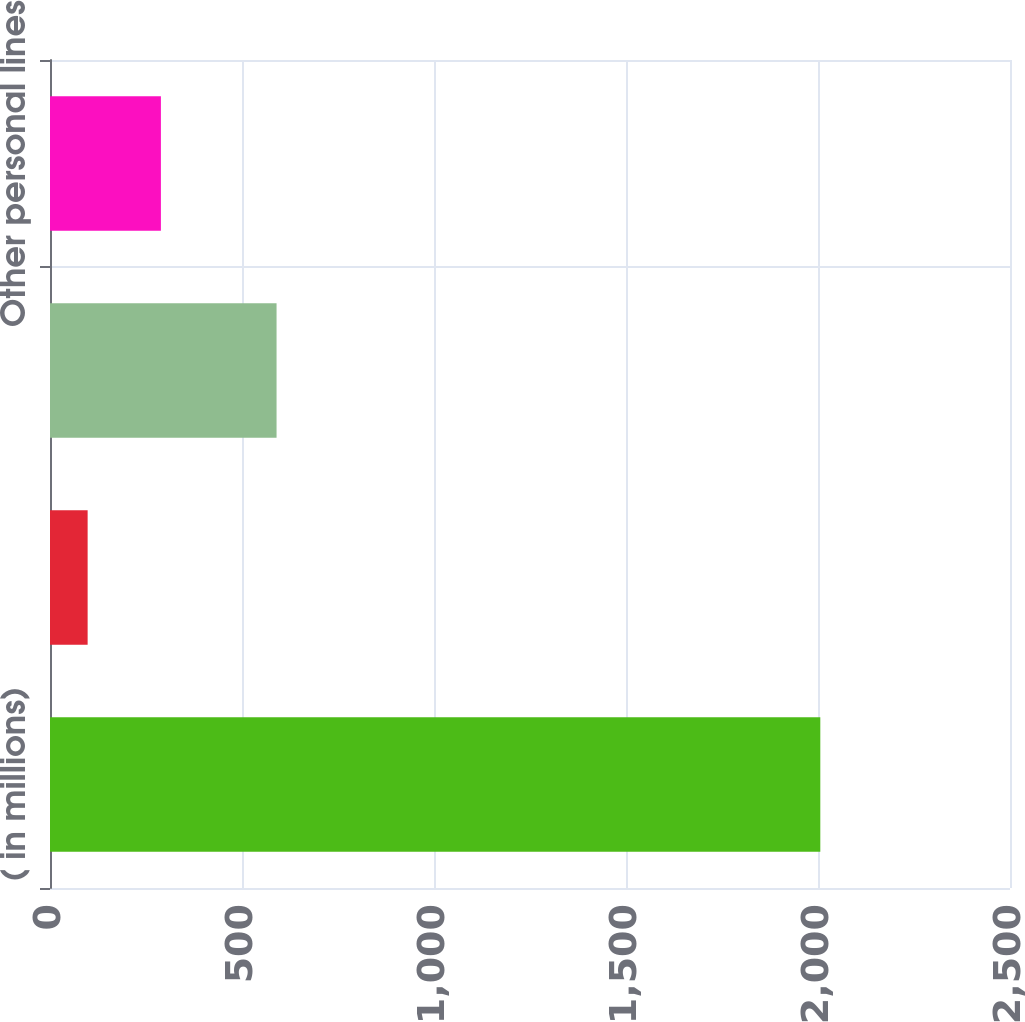Convert chart. <chart><loc_0><loc_0><loc_500><loc_500><bar_chart><fcel>( in millions)<fcel>Non-standard auto<fcel>Homeowners<fcel>Other personal lines<nl><fcel>2006<fcel>98<fcel>590<fcel>288.8<nl></chart> 